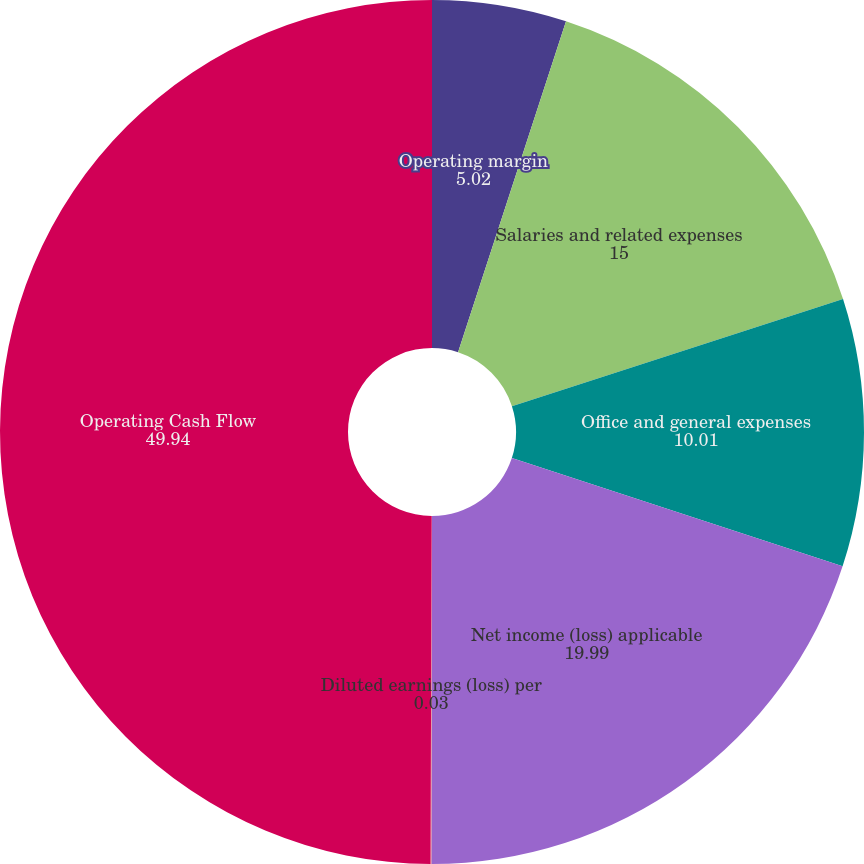<chart> <loc_0><loc_0><loc_500><loc_500><pie_chart><fcel>Operating margin<fcel>Salaries and related expenses<fcel>Office and general expenses<fcel>Net income (loss) applicable<fcel>Diluted earnings (loss) per<fcel>Operating Cash Flow<nl><fcel>5.02%<fcel>15.0%<fcel>10.01%<fcel>19.99%<fcel>0.03%<fcel>49.94%<nl></chart> 